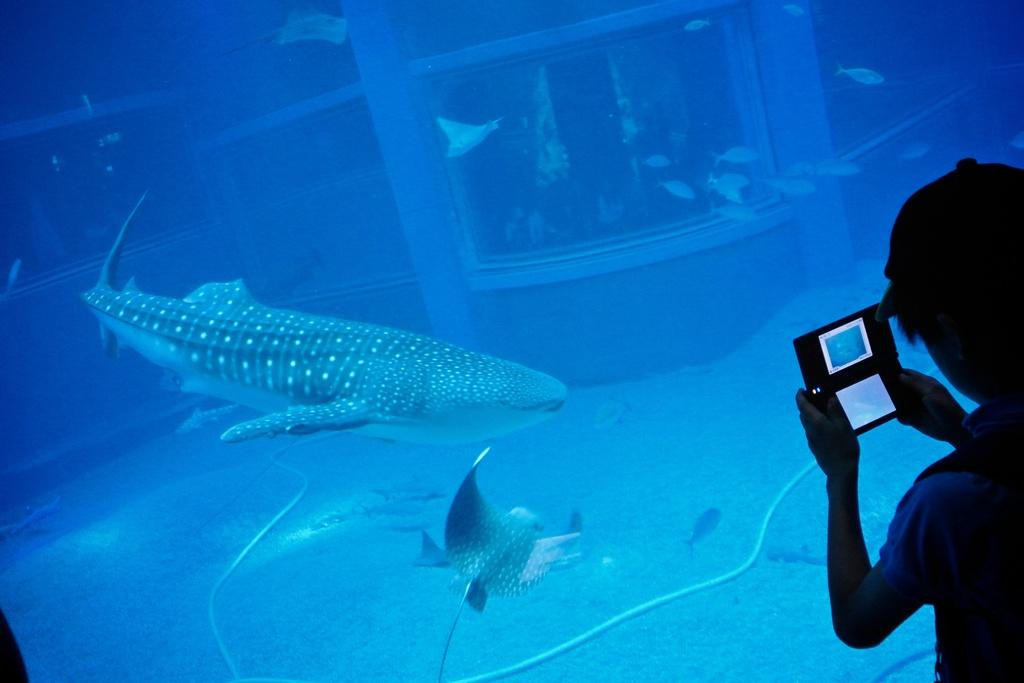What type of animals can be seen in the image? There are aquatic animals in the image. What is the primary element in which the animals are situated? The animals are situated in water, which is visible in the image. Can you describe the person in the image? The person is wearing a dress and cap and is holding a camera. What type of garden can be seen in the image? There is no garden present in the image; it features aquatic animals and a person holding a camera. How many cars are visible in the image? There are no cars visible in the image. 